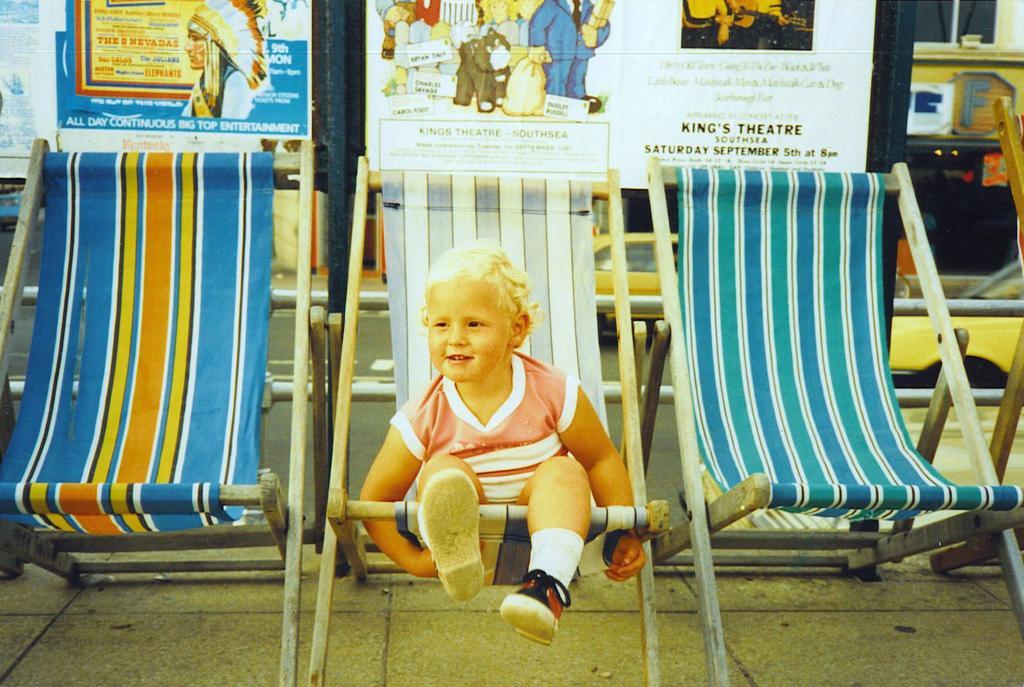Describe this image in one or two sentences. In this image there is a kid sitting in a chair with a smile on his face, beside the kid there are two other empty chairs, behind the kid there are cars passing on the road, behind the cars there are billboards. 